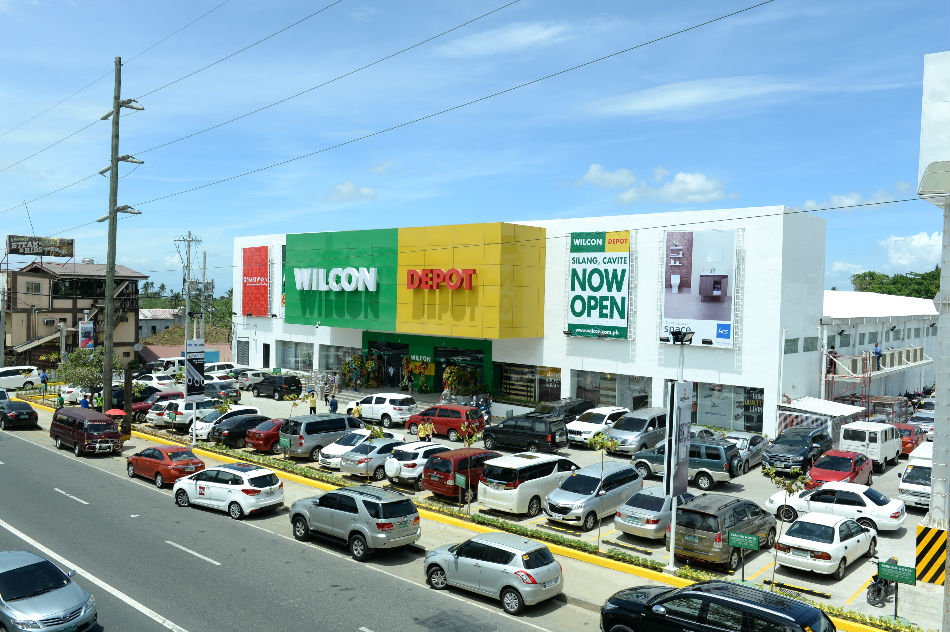Imagine this establishment is part of an alien marketplace replete with interstellar goods and services. What kind of items might be sold here, and how would the layout differ from a terrestrial store? In this imaginative scenario, the establishment might sell an array of fascinating interstellar goods such as anti-gravity vehicles, holographic communication devices, and exotic food items from different planets. The layout would likely be more futuristic, with seamless interactive digital displays, autonomous robots assisting shoppers, and perhaps a teleportation area for instant delivery of large items. The parking lot could feature spaces for various spacecraft, and signage might be in multiple alien languages, using symbols and colors to cater to a diverse interstellar clientele. The architecture might include curvilinear designs and glowing elements, making the building itself a spectacle of advanced alien engineering. 